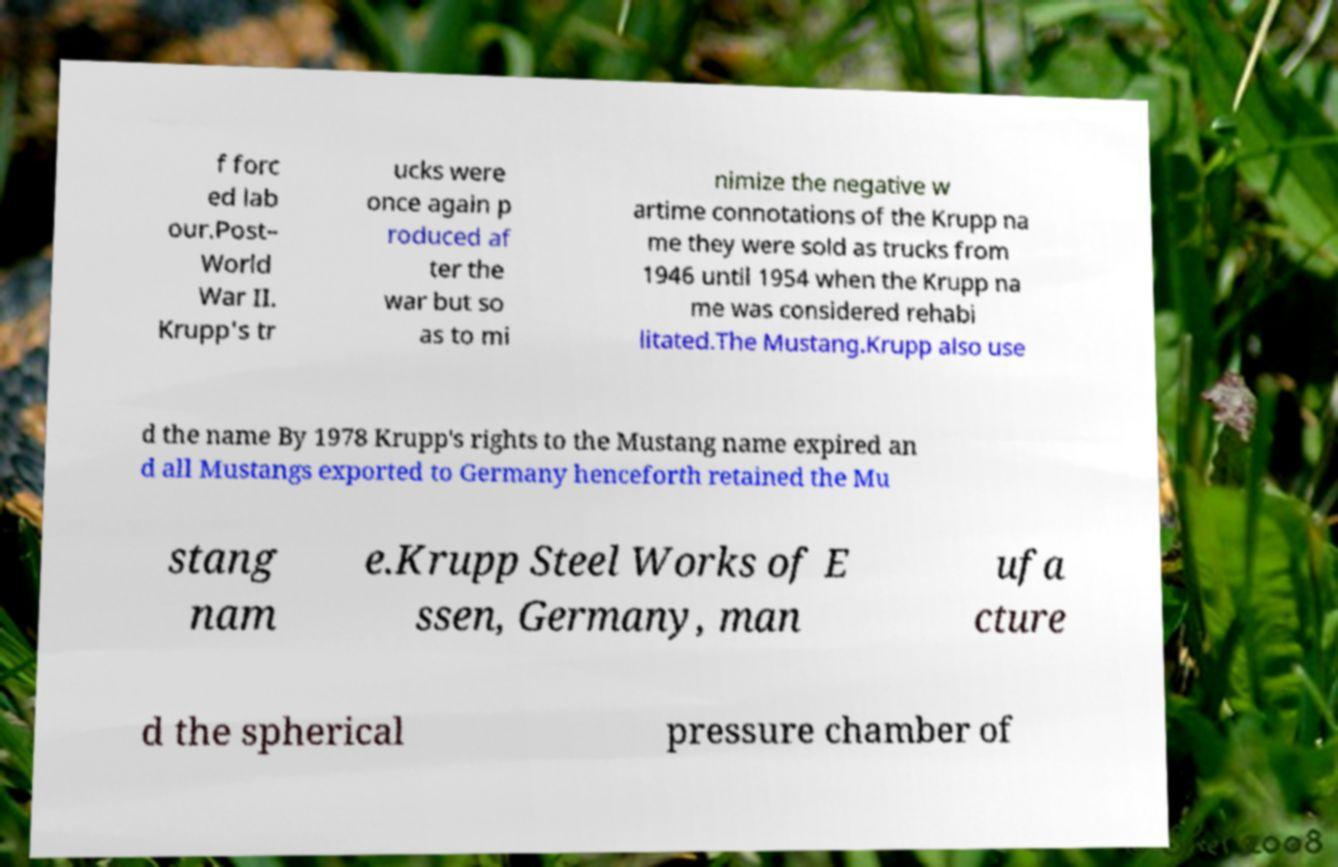I need the written content from this picture converted into text. Can you do that? f forc ed lab our.Post– World War II. Krupp's tr ucks were once again p roduced af ter the war but so as to mi nimize the negative w artime connotations of the Krupp na me they were sold as trucks from 1946 until 1954 when the Krupp na me was considered rehabi litated.The Mustang.Krupp also use d the name By 1978 Krupp's rights to the Mustang name expired an d all Mustangs exported to Germany henceforth retained the Mu stang nam e.Krupp Steel Works of E ssen, Germany, man ufa cture d the spherical pressure chamber of 